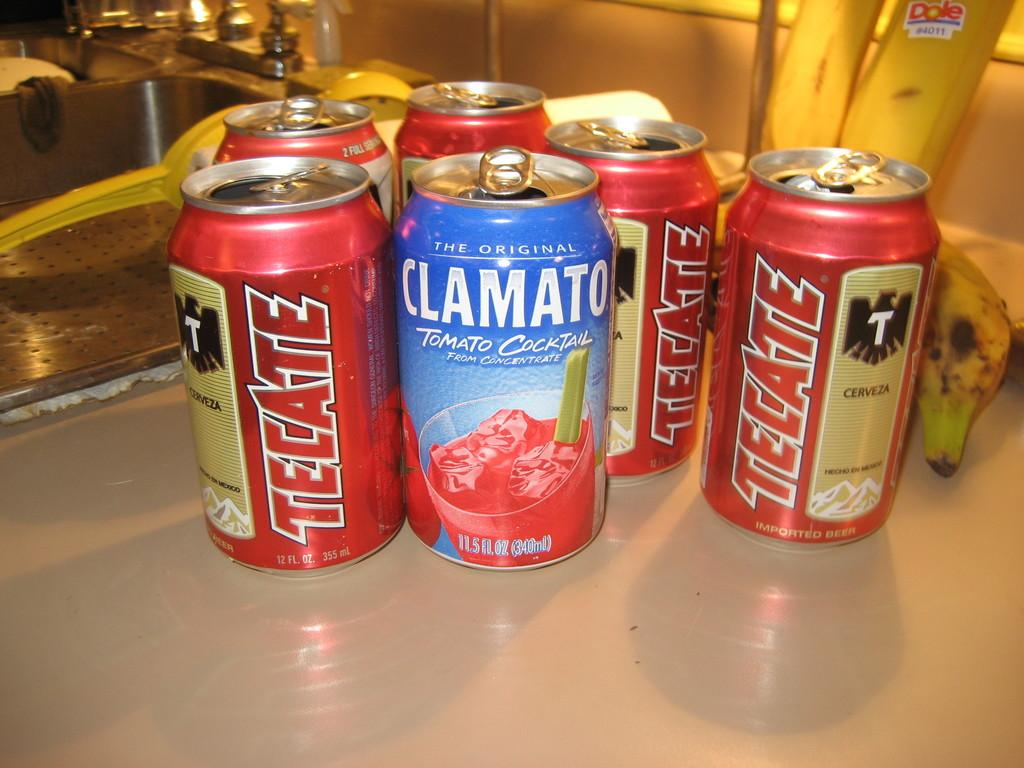<image>
Render a clear and concise summary of the photo. Various cans of Tecate beer and Clamato in front of banana peels 